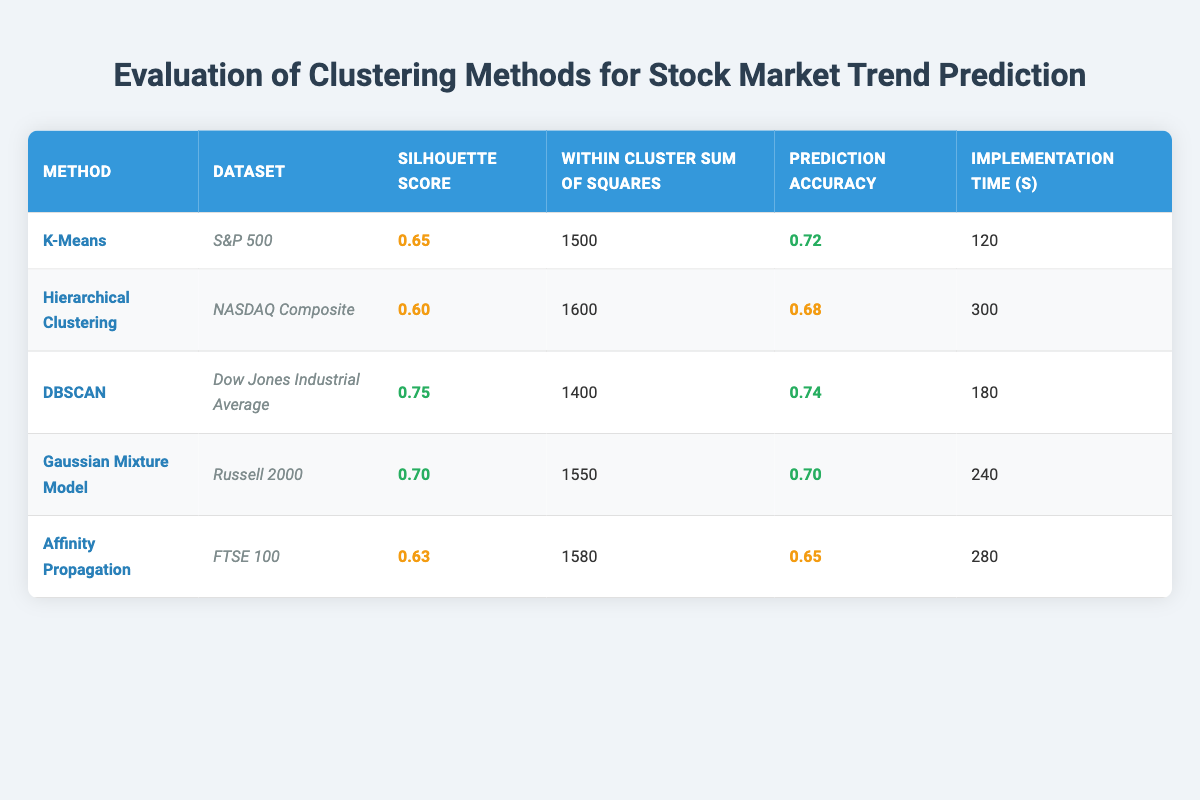What is the silhouette score for DBSCAN? The silhouette score is explicitly listed in the table for each clustering method. For DBSCAN, the silhouette score is 0.75.
Answer: 0.75 Which clustering method had the longest implementation time? By comparing the "Implementation Time (s)" column for all methods, Hierarchical Clustering has the highest value at 300 seconds.
Answer: Hierarchical Clustering What is the average prediction accuracy of K-Means and Gaussian Mixture Model? The prediction accuracies for K-Means (0.72) and Gaussian Mixture Model (0.70) can be summed (0.72 + 0.70 = 1.42) and then divided by 2 to find the average (1.42 / 2 = 0.71).
Answer: 0.71 Is the within-cluster sum of squares for Affinity Propagation greater than that for DBSCAN? The within-cluster sum of squares for Affinity Propagation is 1580, and for DBSCAN, it is 1400. Since 1580 is greater than 1400, this statement is true.
Answer: Yes What is the prediction accuracy difference between the best and worst clustering methods? The best prediction accuracy is for DBSCAN at 0.74, while the worst is for Affinity Propagation at 0.65. The difference can be calculated as 0.74 - 0.65 = 0.09.
Answer: 0.09 